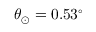Convert formula to latex. <formula><loc_0><loc_0><loc_500><loc_500>\theta _ { \odot } = 0 . 5 3 ^ { \circ }</formula> 